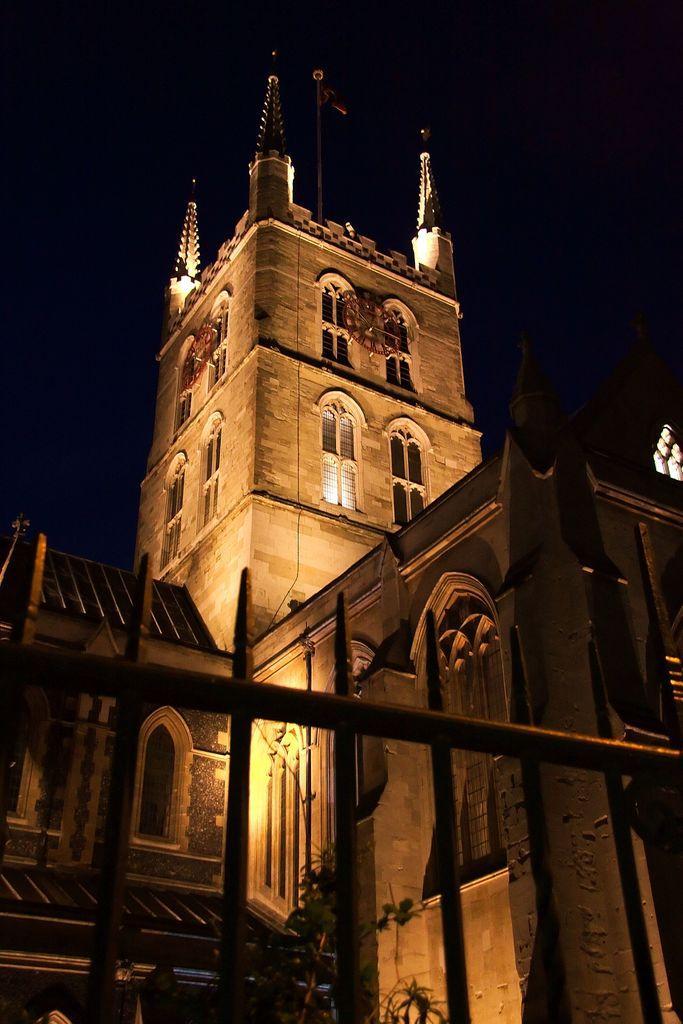How would you summarize this image in a sentence or two? In this image we can see a fence and a plant. In the background we can see buildings, windows, flagpole on the building and lights. 